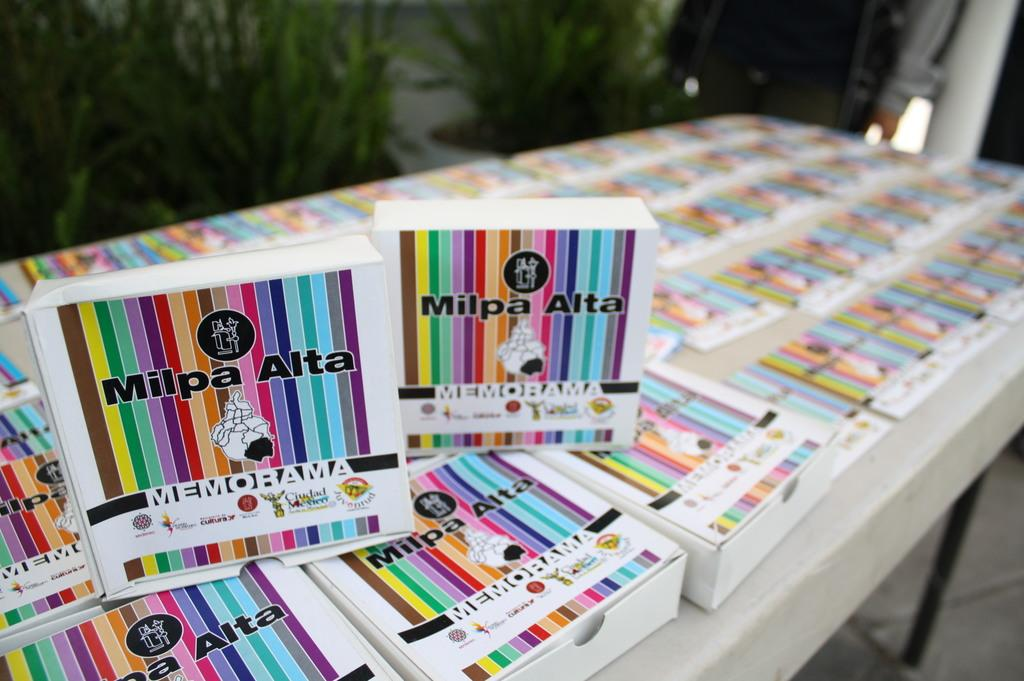What objects are on the table in the image? There are many books on the table in the image. What can be seen in the background of the image? There are plants visible in the background of the image. What type of cable is connected to the van in the image? There is no van or cable present in the image. How often do the plants need to be washed in the image? The plants do not need to be washed in the image, as they are not living organisms that require cleaning. 